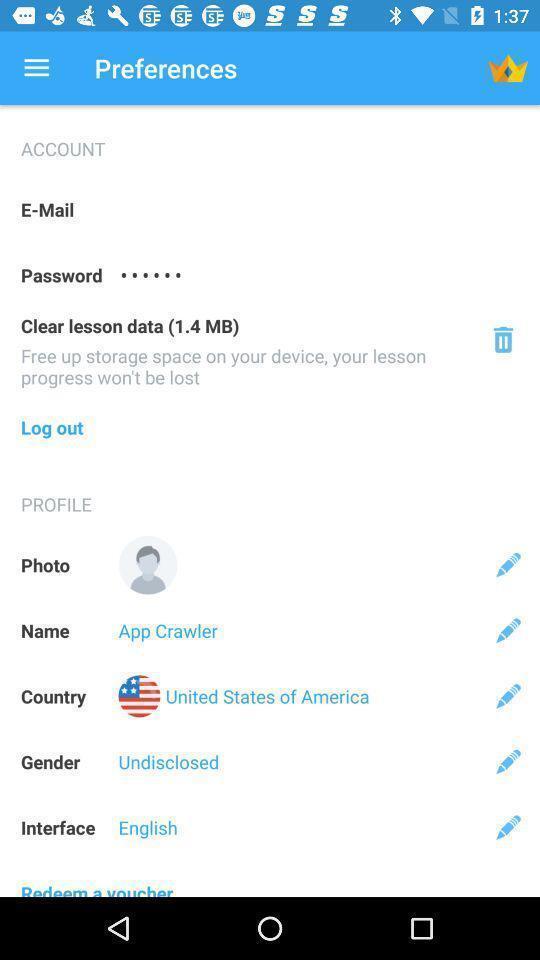Provide a description of this screenshot. Screen showing preferences page. 